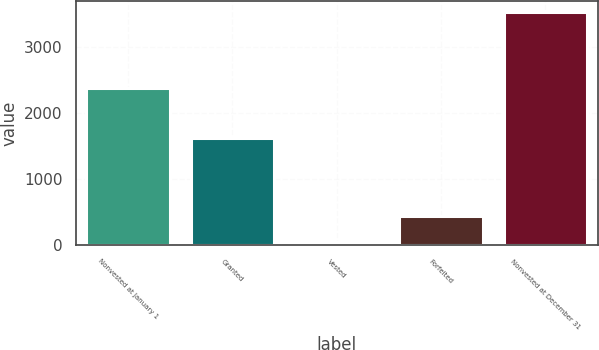Convert chart. <chart><loc_0><loc_0><loc_500><loc_500><bar_chart><fcel>Nonvested at January 1<fcel>Granted<fcel>Vested<fcel>Forfeited<fcel>Nonvested at December 31<nl><fcel>2380<fcel>1622<fcel>39<fcel>444<fcel>3519<nl></chart> 